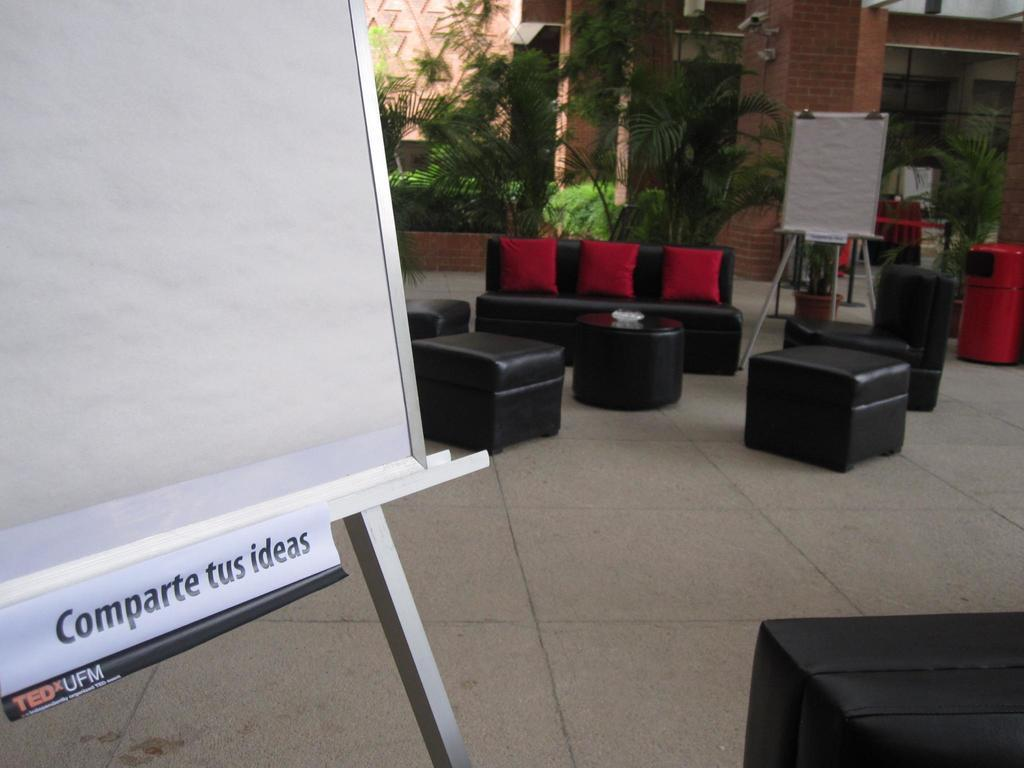How many boards are visible in the image? There are 2 boards in the image. What type of furniture is present in the image? There is a sofa and chairs in the image. What can be seen in the background of the image? There are plants and a building in the background of the image. What type of twig can be seen hanging on the wall in the image? There is no twig present in the image. What type of picture is hanging on the wall in the image? There is no picture hanging on the wall in the image. 